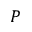Convert formula to latex. <formula><loc_0><loc_0><loc_500><loc_500>P</formula> 